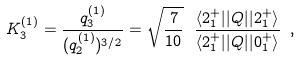Convert formula to latex. <formula><loc_0><loc_0><loc_500><loc_500>K _ { 3 } ^ { ( 1 ) } = \frac { q _ { 3 } ^ { ( 1 ) } } { ( q _ { 2 } ^ { ( 1 ) } ) ^ { 3 / 2 } } = \sqrt { \frac { 7 } { 1 0 } } \ \frac { \langle 2 ^ { + } _ { 1 } | | Q | | 2 ^ { + } _ { 1 } \rangle } { \langle 2 ^ { + } _ { 1 } | | Q | | 0 ^ { + } _ { 1 } \rangle } \ ,</formula> 